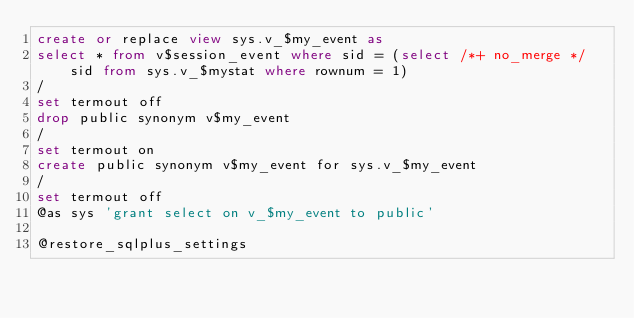<code> <loc_0><loc_0><loc_500><loc_500><_SQL_>create or replace view sys.v_$my_event as
select * from v$session_event where sid = (select /*+ no_merge */ sid from sys.v_$mystat where rownum = 1)
/
set termout off
drop public synonym v$my_event
/
set termout on
create public synonym v$my_event for sys.v_$my_event
/
set termout off
@as sys 'grant select on v_$my_event to public'

@restore_sqlplus_settings
</code> 